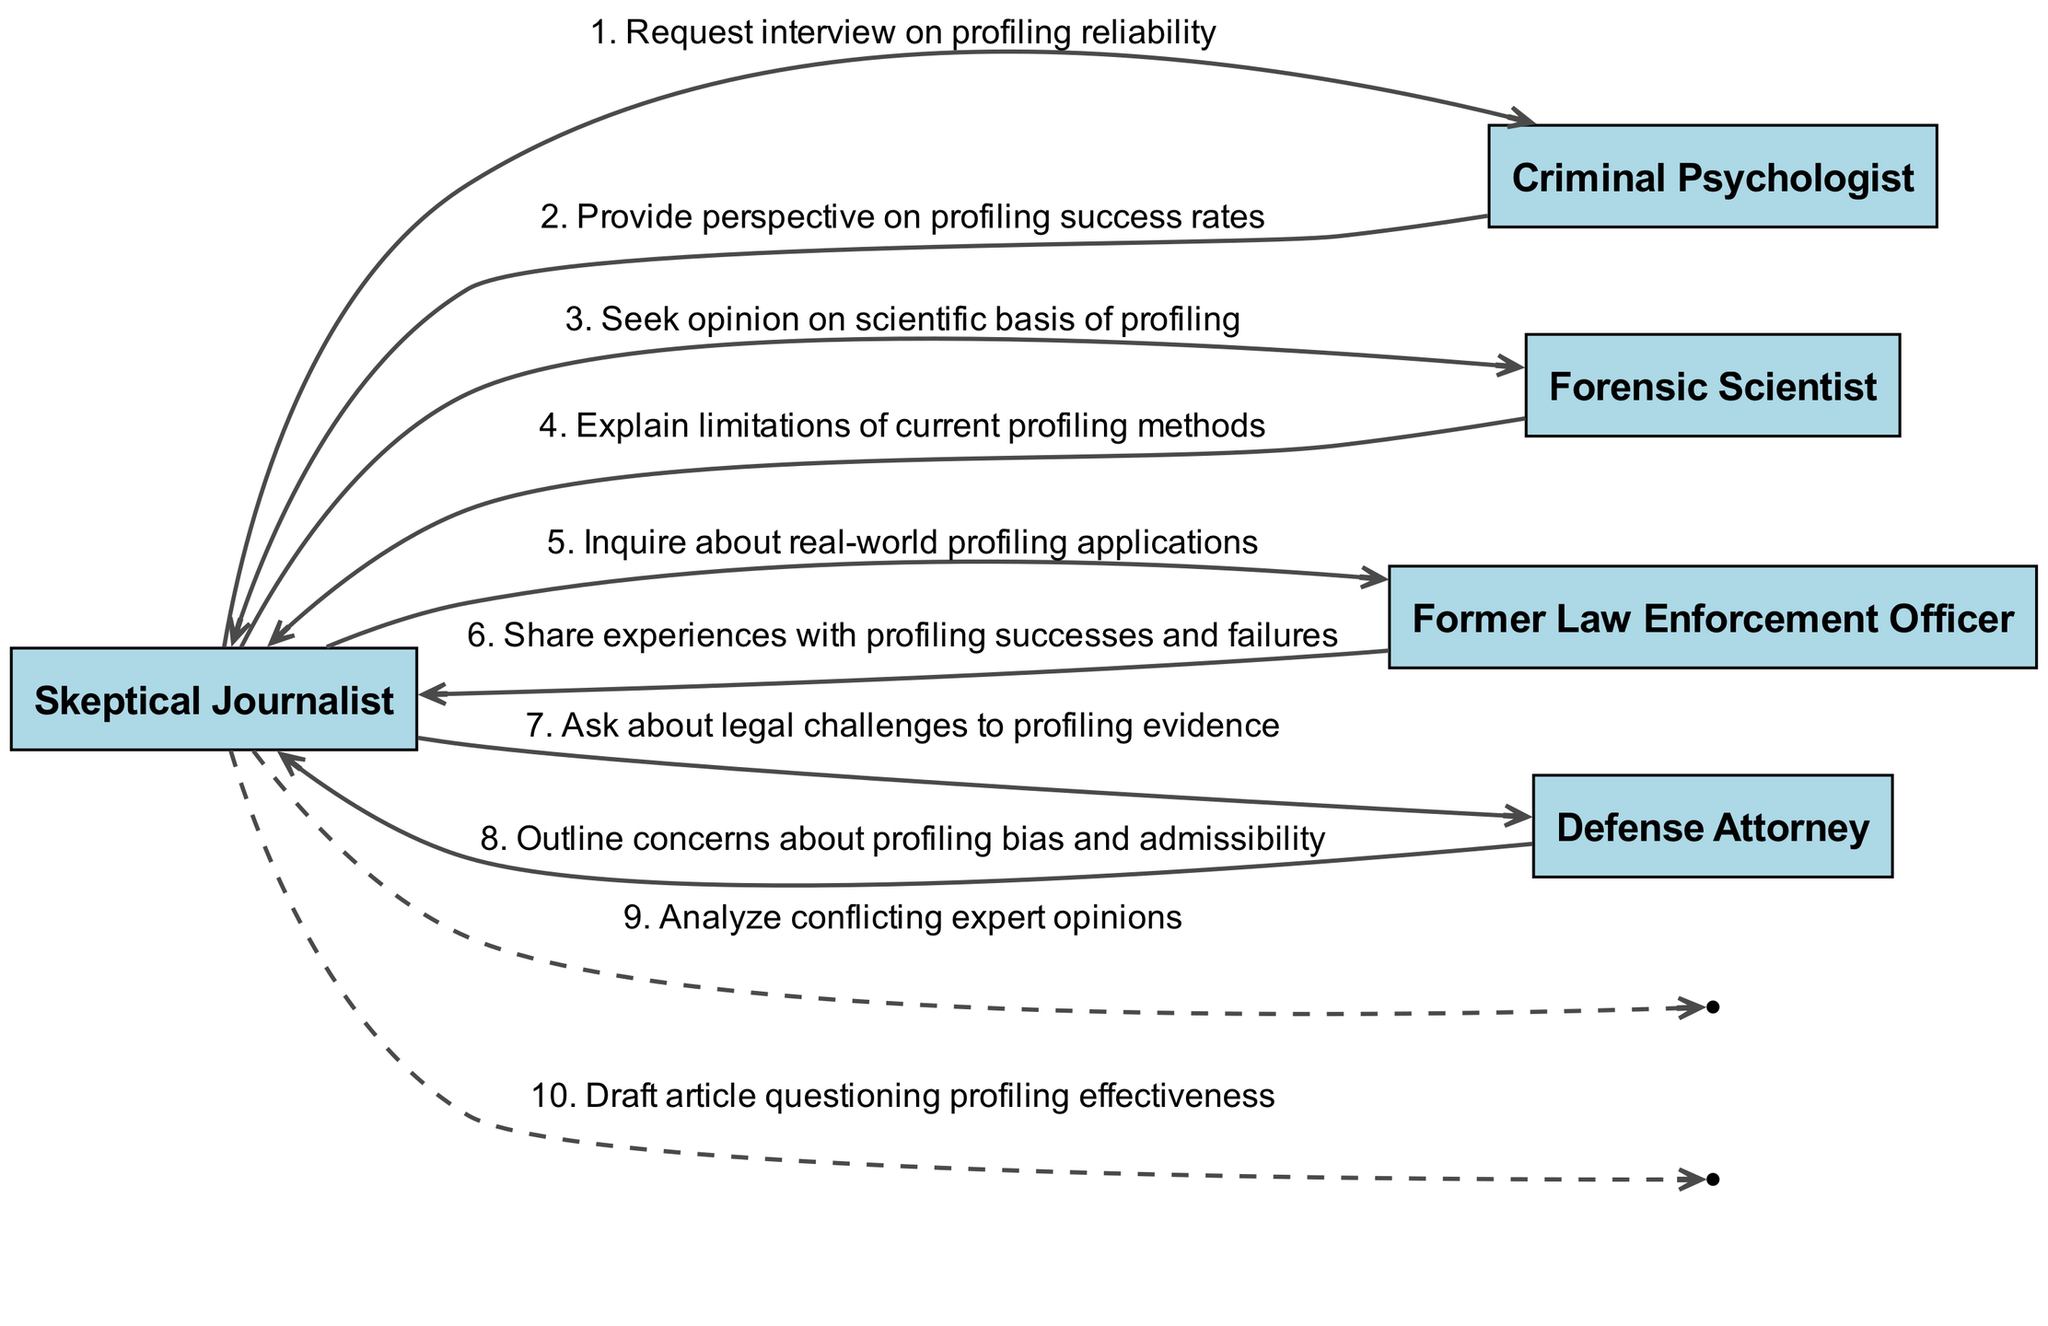What's the total number of actors in the diagram? There are five actors in the diagram: Skeptical Journalist, Criminal Psychologist, Forensic Scientist, Former Law Enforcement Officer, and Defense Attorney. Thus, the total number of actors is five.
Answer: 5 Which actor is the first to receive a message? The first message is sent from the Skeptical Journalist to the Criminal Psychologist, indicating that the Criminal Psychologist is the first actor to receive a message.
Answer: Criminal Psychologist How many messages does the Skeptical Journalist send? The Skeptical Journalist sends four messages in total: one to the Criminal Psychologist, one to the Forensic Scientist, one to the Former Law Enforcement Officer, and one to the Defense Attorney. Therefore, the Skeptical Journalist sends four messages.
Answer: 4 What is the content of the message from the Defense Attorney to the Skeptical Journalist? The message from the Defense Attorney to the Skeptical Journalist outlines concerns about profiling bias and admissibility, which represents the content of that message.
Answer: Outline concerns about profiling bias and admissibility Which two actors exchange messages about profiling's real-world applications? The Skeptical Journalist inquires about real-world profiling applications and receives a response from the Former Law Enforcement Officer, making these two the actors exchanging messages on this topic.
Answer: Skeptical Journalist and Former Law Enforcement Officer What kind of response does the Skeptical Journalist receive from the Criminal Psychologist? The Skeptical Journalist receives a perspective on profiling success rates from the Criminal Psychologist as a response to the initial interview request.
Answer: Provide perspective on profiling success rates How many self-messages does the Skeptical Journalist have in the diagram? The Skeptical Journalist sends two self-messages, one analyzing conflicting expert opinions and the other drafted an article questioning profiling effectiveness. So, the Skeptical Journalist has two self-messages.
Answer: 2 Which actor provides an explanation on the limitations of profiling methods? The Forensic Scientist gives an explanation regarding the limitations of current profiling methods, making this actor the one providing that information.
Answer: Forensic Scientist What is the last action taken by the Skeptical Journalist in the sequence? The last action taken by the Skeptical Journalist is drafting an article questioning profiling effectiveness. This is indicated as the final step in the sequence flow.
Answer: Draft article questioning profiling effectiveness 